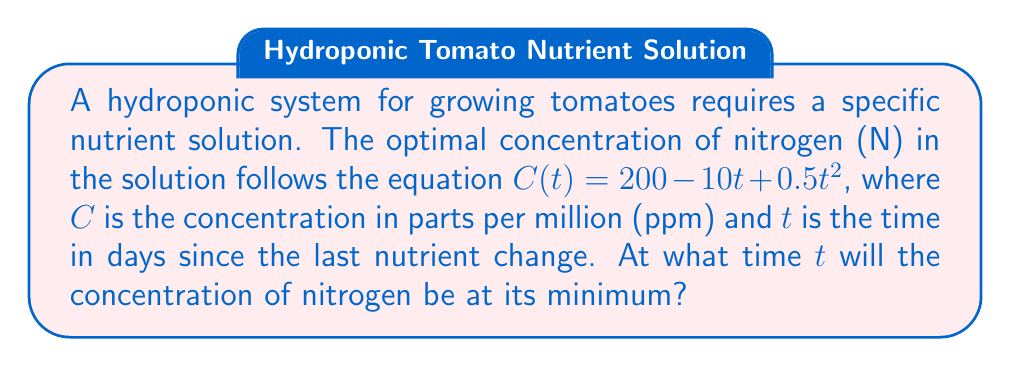Can you answer this question? To find the minimum concentration of nitrogen, we need to follow these steps:

1) The concentration $C$ is a function of time $t$. To find the minimum, we need to find the time $t$ where the derivative of $C$ with respect to $t$ is zero.

2) Let's find the derivative of $C(t)$:
   $$\frac{dC}{dt} = -10 + t$$

3) Set the derivative equal to zero and solve for $t$:
   $$-10 + t = 0$$
   $$t = 10$$

4) To confirm this is a minimum (not a maximum), we can check the second derivative:
   $$\frac{d^2C}{dt^2} = 1$$
   Since this is positive, we confirm that $t = 10$ gives a minimum.

5) Therefore, the concentration of nitrogen will be at its minimum 10 days after the last nutrient change.

This problem demonstrates the application of calculus in optimizing nutrient concentrations, a crucial aspect of hydroponic farming which is becoming increasingly important in sustainable agriculture practices in Tamil Nadu and around the world.
Answer: 10 days 